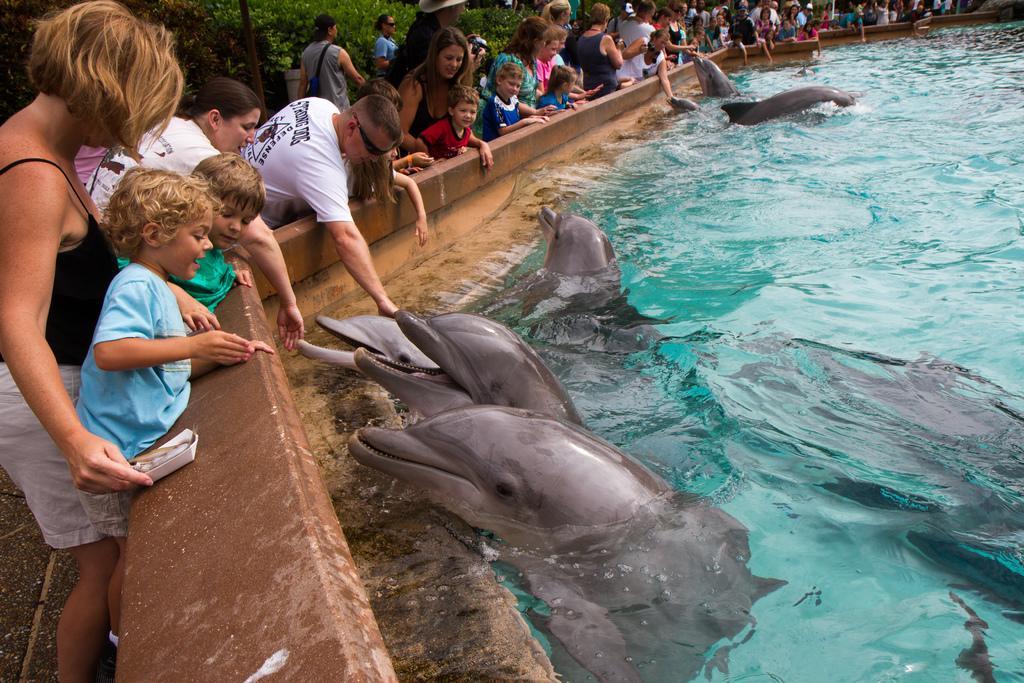How would you summarize this image in a sentence or two? In this image we can see dolphins in the water and these people are standing near the wall. In the background, we can see these people walking on the road and trees. 